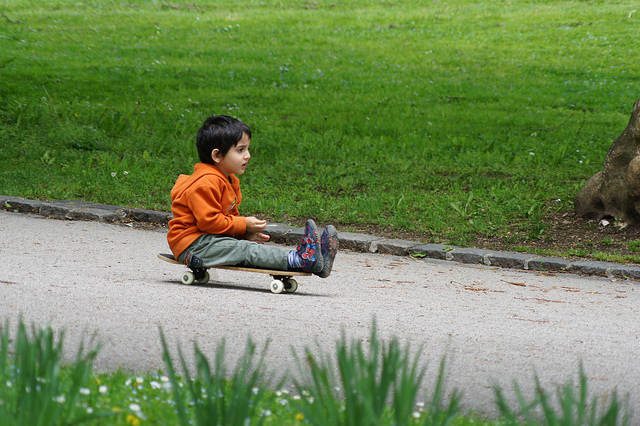<image>What is the motif etched or painted onto the window? There is no window in the image. However, if there was, it could potentially have a motif of a flower or star. What government document is needed to partake in this activity? It is ambiguous what government document is needed to partake in this activity. It can be a green card, birth certificate or none of them. What is the motif etched or painted onto the window? There is no window in the image. What government document is needed to partake in this activity? It is unclear what government document is needed to partake in this activity. The answers are ambiguous. 